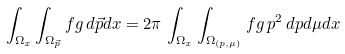Convert formula to latex. <formula><loc_0><loc_0><loc_500><loc_500>\int _ { \Omega _ { x } } \int _ { \Omega _ { \vec { p } } } f g \, d \vec { p } d x = 2 \pi \, \int _ { \Omega _ { x } } \int _ { \Omega _ { ( p , \mu ) } } f g \, p ^ { 2 } \, d p d \mu d x</formula> 